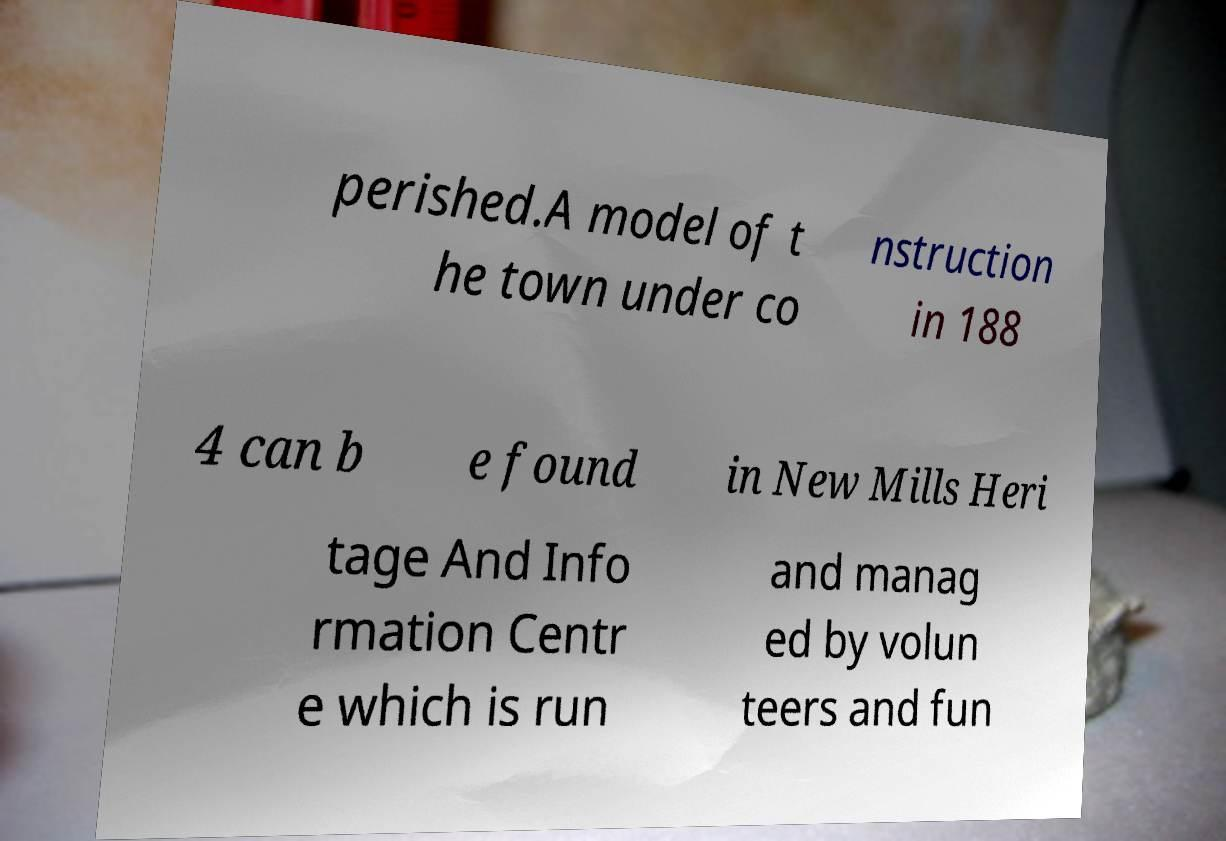Please read and relay the text visible in this image. What does it say? perished.A model of t he town under co nstruction in 188 4 can b e found in New Mills Heri tage And Info rmation Centr e which is run and manag ed by volun teers and fun 